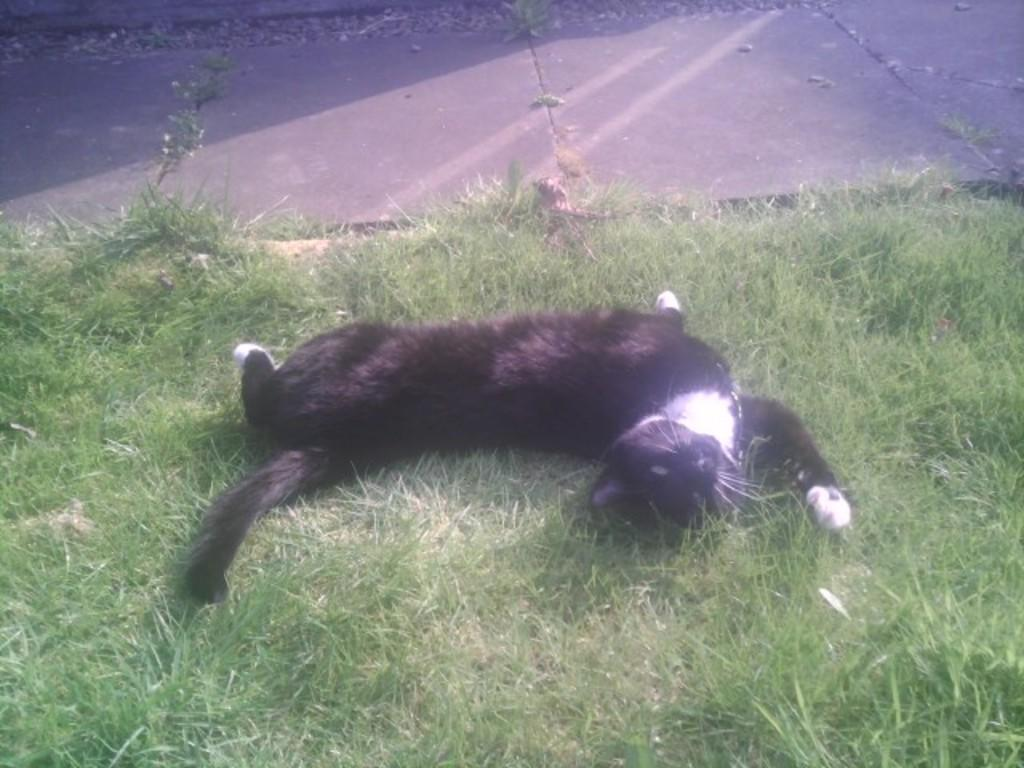What animal can be seen in the image? There is a cat in the image. Where is the cat located? The cat is on the grass. What type of surface is visible beside the grass? The ground beside the grass is visible in the image. What time of day is the cat fighting with the zinc in the image? There is no cat fighting with zinc in the image, nor is there any indication of the time of day. 